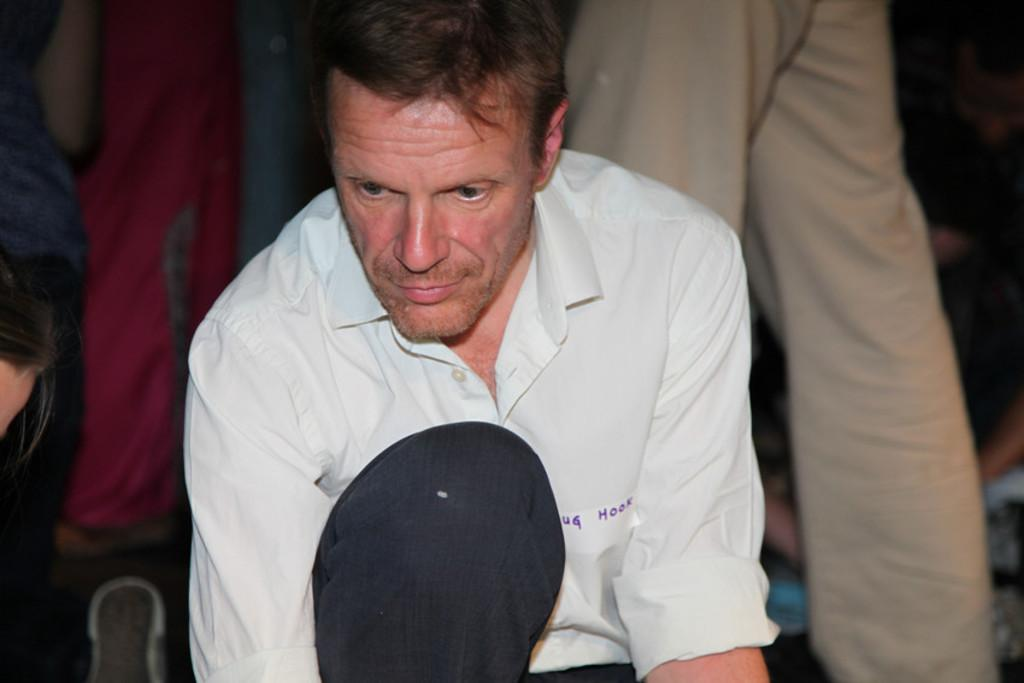Who is present in the image? There is a person in the image. What can be seen on the person's shirt? The person has a sticker on their shirt. What is written on the sticker? There is text on the sticker. Can you describe the surroundings of the person? There are other people in the background of the image. Is the person in the image sleeping or burning? The person in the image is neither sleeping nor burning; they are standing with a sticker on their shirt. Can you describe any bites or biting actions in the image? There are no bites or biting actions depicted in the image. 